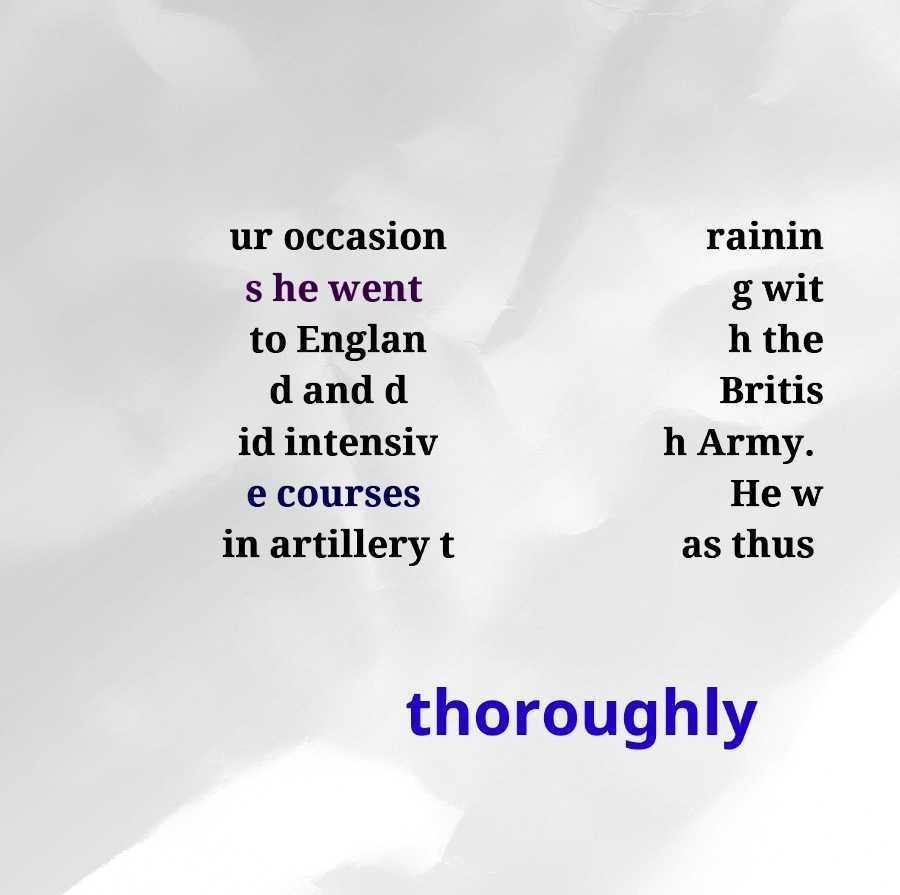There's text embedded in this image that I need extracted. Can you transcribe it verbatim? ur occasion s he went to Englan d and d id intensiv e courses in artillery t rainin g wit h the Britis h Army. He w as thus thoroughly 